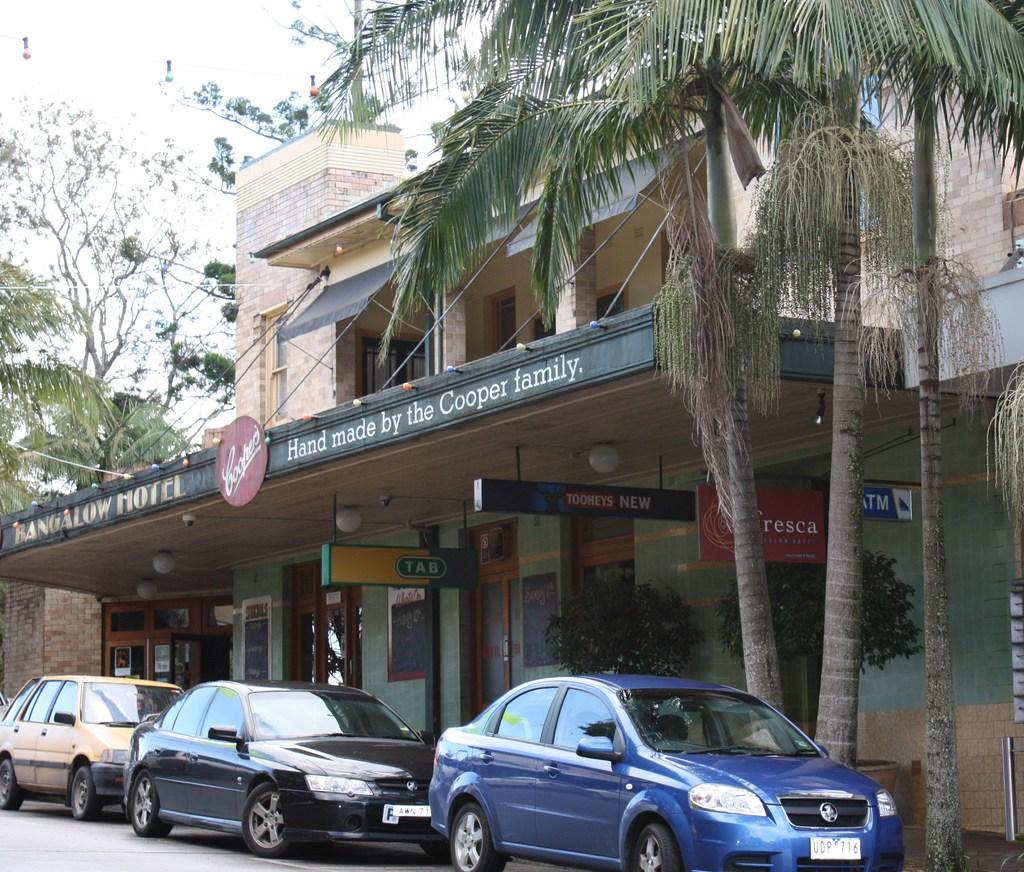What type of structures can be seen in the image? There are buildings in the image. What other natural elements are present in the image? There are trees in the image. What mode of transportation can be seen in the image? There are cars parked in the image. Are there any signs or messages visible in the image? Yes, there are boards with text in the image. How would you describe the weather based on the image? The sky is cloudy in the image. What type of feeling can be seen in the image? There is no feeling present in the image; it is a visual representation of buildings, trees, cars, boards, and the sky. What type of produce is being harvested in the image? There is no produce or harvesting activity depicted in the image. 